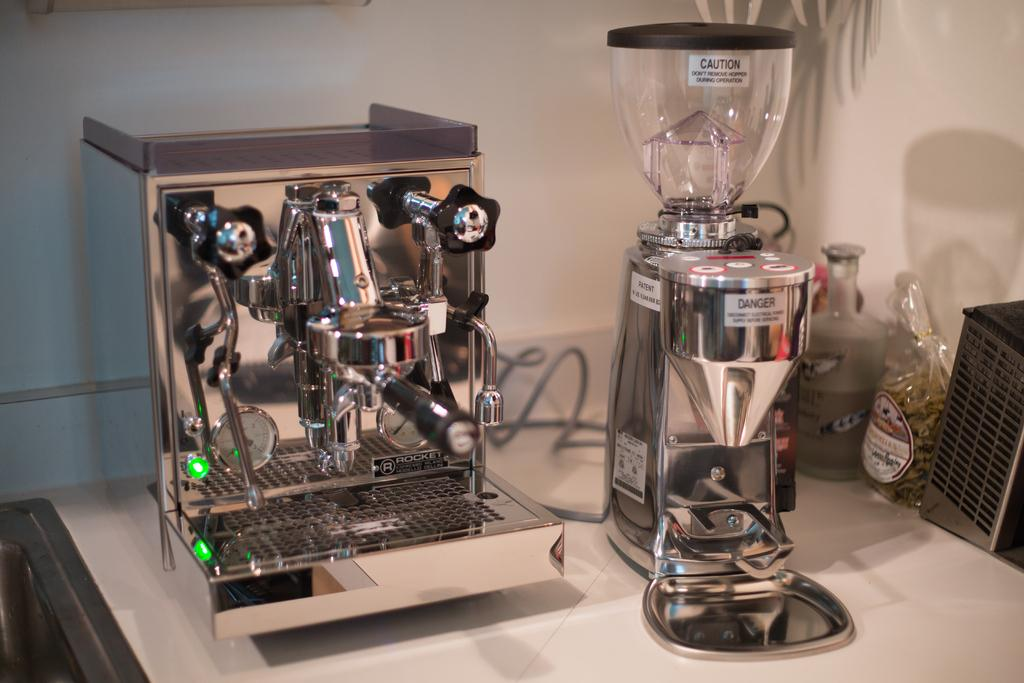<image>
Present a compact description of the photo's key features. A set of chromed machines with the one on the right having a Danger tag in its center. 